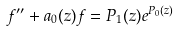<formula> <loc_0><loc_0><loc_500><loc_500>f ^ { \prime \prime } + a _ { 0 } ( z ) f = P _ { 1 } ( z ) e ^ { P _ { 0 } ( z ) }</formula> 